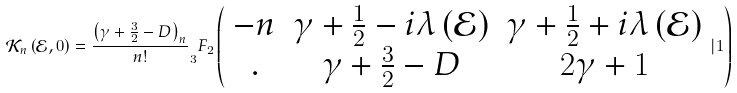<formula> <loc_0><loc_0><loc_500><loc_500>\mathcal { K } _ { n } \left ( \mathcal { E } , 0 \right ) = \frac { \left ( \gamma + \frac { 3 } { 2 } - D \right ) _ { n } } { n ! } _ { 3 } F _ { 2 } \left ( \begin{array} { c c c } - n & \gamma + \frac { 1 } { 2 } - i \lambda \left ( \mathcal { E } \right ) & \gamma + \frac { 1 } { 2 } + i \lambda \left ( \mathcal { E } \right ) \\ . & \gamma + \frac { 3 } { 2 } - D & 2 \gamma + 1 \end{array} | 1 \right )</formula> 